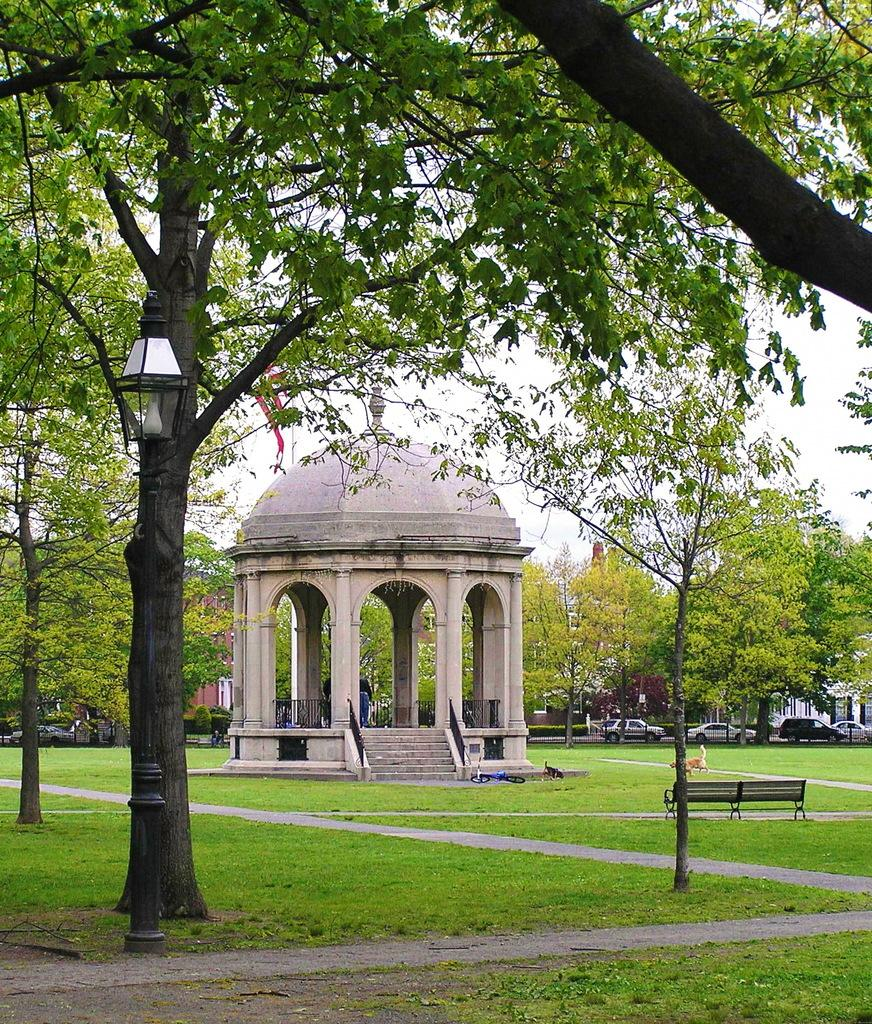What can be found in the middle of the image? In the middle of the image, there are trees, lights, benches, and grass. Are there any animals present in the image? Yes, there is a dog in the image. What type of vehicle can be seen in the image? There is a cycle in the image. What kind of area is depicted in the image? The image shows a picnic spot. What other natural elements are present in the image? There are plants in the image. Are there any man-made structures visible? Yes, there are cars in the image. What is the terrain like at the bottom of the image? There is land at the bottom of the image. What is the pole at the bottom of the image used for? The pole at the bottom of the image is not specified, but it could be a utility pole or a signpost. What is visible at the top of the image? Sky is visible at the top of the image. Where is the table located in the image? There is no table present in the image. Can you see any waves in the image? There are no waves visible in the image; it is a land-based picnic spot. What type of furniture can be found in the bedroom in the image? There is no bedroom present in the image. 